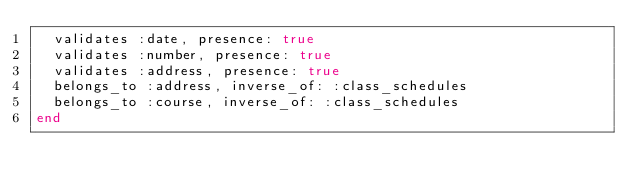<code> <loc_0><loc_0><loc_500><loc_500><_Ruby_>  validates :date, presence: true
  validates :number, presence: true
  validates :address, presence: true
  belongs_to :address, inverse_of: :class_schedules
  belongs_to :course, inverse_of: :class_schedules
end
</code> 